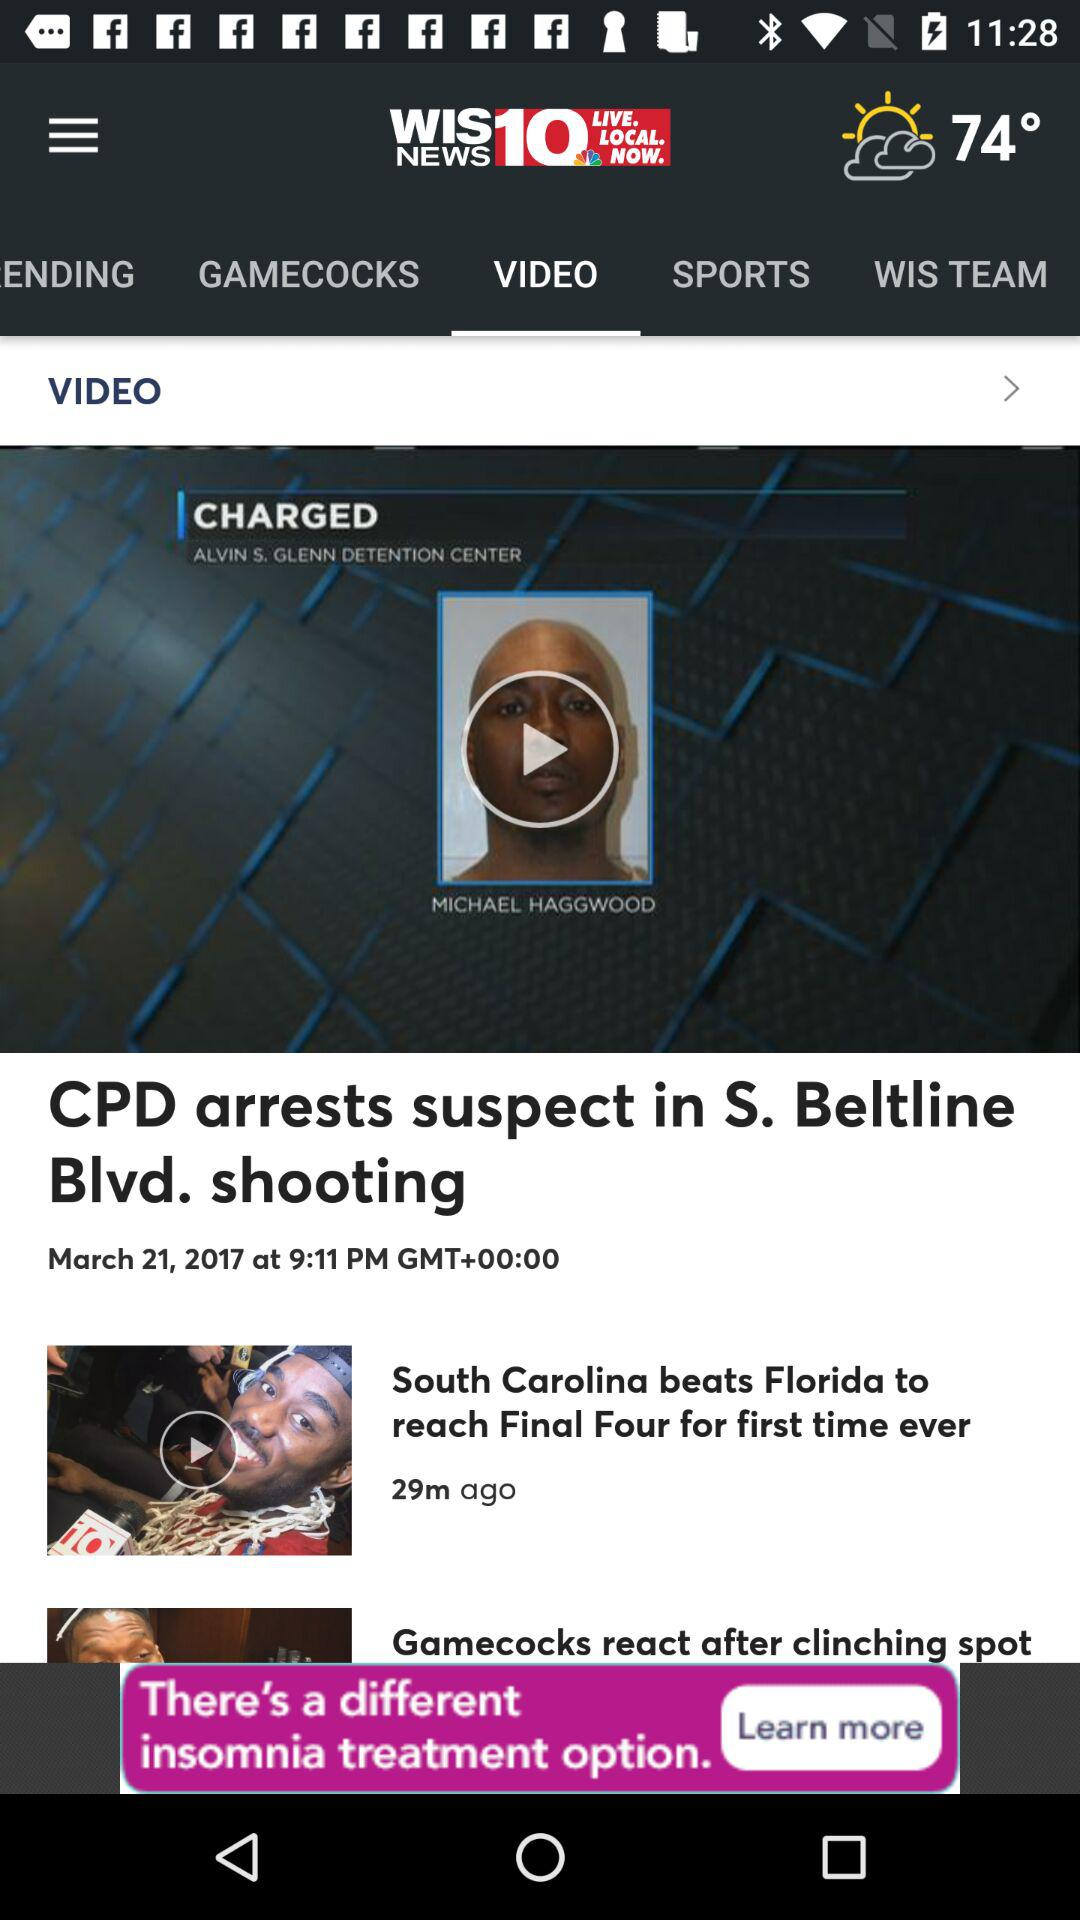What is the temperature? The temperature is 74°. 